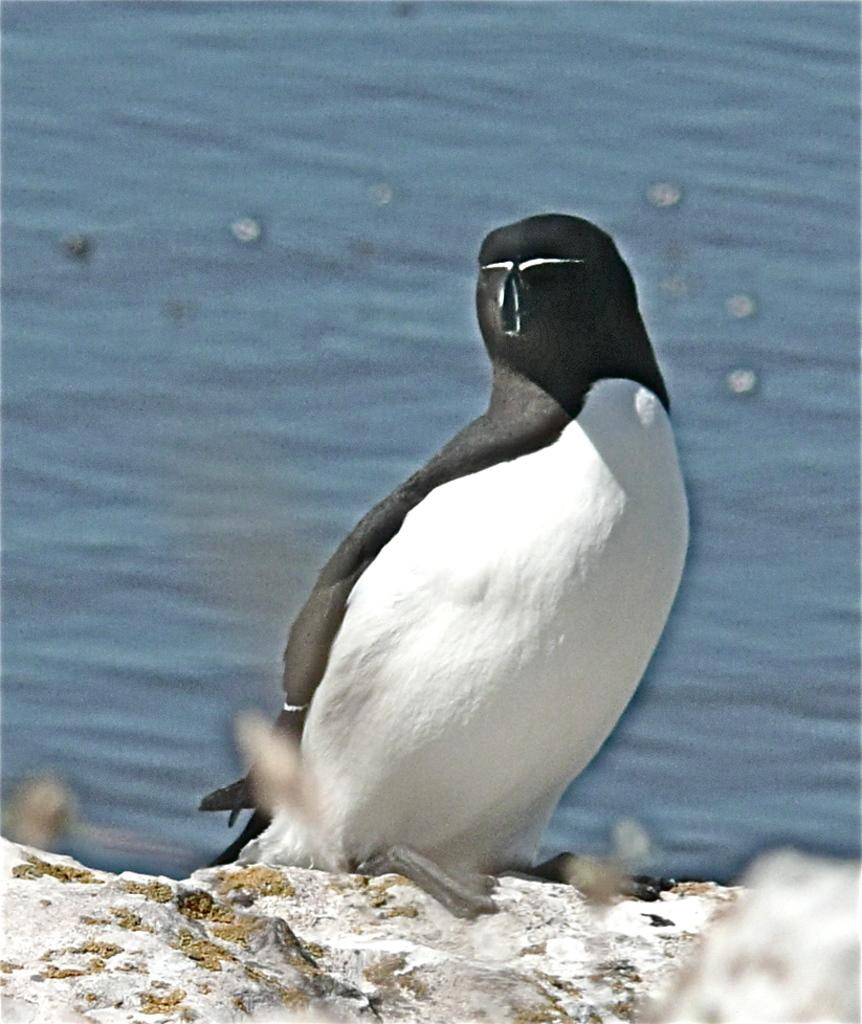What can be observed about the background of the image? The background portion of the picture is blurred. What natural element is visible in the image? There is water visible in the image. What type of animal is present in the image? There is a penguin in the image. On what surface is the penguin standing? The penguin is on a rock surface. What direction is the penguin facing in the image? The provided facts do not mention the direction the penguin is facing, so it cannot be determined from the image. What type of ray is swimming in the water in the image? There is no ray visible in the image; it only features a penguin on a rock surface. 